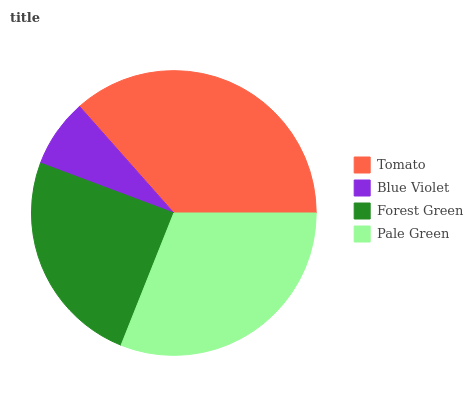Is Blue Violet the minimum?
Answer yes or no. Yes. Is Tomato the maximum?
Answer yes or no. Yes. Is Forest Green the minimum?
Answer yes or no. No. Is Forest Green the maximum?
Answer yes or no. No. Is Forest Green greater than Blue Violet?
Answer yes or no. Yes. Is Blue Violet less than Forest Green?
Answer yes or no. Yes. Is Blue Violet greater than Forest Green?
Answer yes or no. No. Is Forest Green less than Blue Violet?
Answer yes or no. No. Is Pale Green the high median?
Answer yes or no. Yes. Is Forest Green the low median?
Answer yes or no. Yes. Is Tomato the high median?
Answer yes or no. No. Is Pale Green the low median?
Answer yes or no. No. 